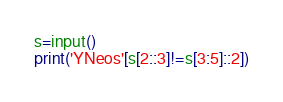Convert code to text. <code><loc_0><loc_0><loc_500><loc_500><_Cython_>s=input()
print('YNeos'[s[2::3]!=s[3:5]::2])</code> 